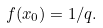<formula> <loc_0><loc_0><loc_500><loc_500>f ( x _ { 0 } ) = 1 / q .</formula> 